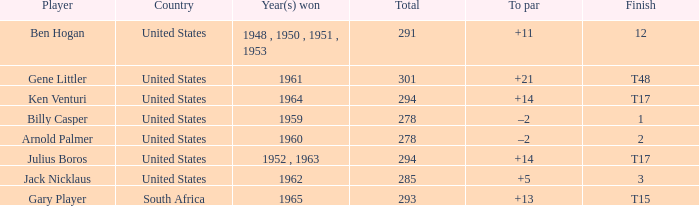What is Year(s) Won, when Total is less than 285? 1959, 1960. 